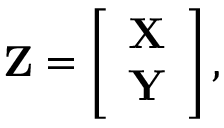<formula> <loc_0><loc_0><loc_500><loc_500>Z = \left [ \begin{array} { c } { X } \\ { Y } \end{array} \right ] ,</formula> 